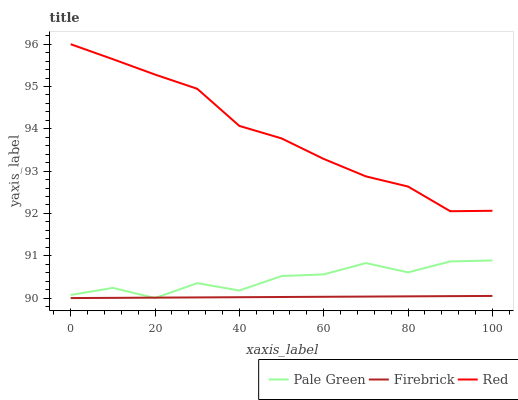Does Firebrick have the minimum area under the curve?
Answer yes or no. Yes. Does Red have the maximum area under the curve?
Answer yes or no. Yes. Does Pale Green have the minimum area under the curve?
Answer yes or no. No. Does Pale Green have the maximum area under the curve?
Answer yes or no. No. Is Firebrick the smoothest?
Answer yes or no. Yes. Is Pale Green the roughest?
Answer yes or no. Yes. Is Red the smoothest?
Answer yes or no. No. Is Red the roughest?
Answer yes or no. No. Does Red have the lowest value?
Answer yes or no. No. Does Pale Green have the highest value?
Answer yes or no. No. Is Pale Green less than Red?
Answer yes or no. Yes. Is Red greater than Firebrick?
Answer yes or no. Yes. Does Pale Green intersect Red?
Answer yes or no. No. 